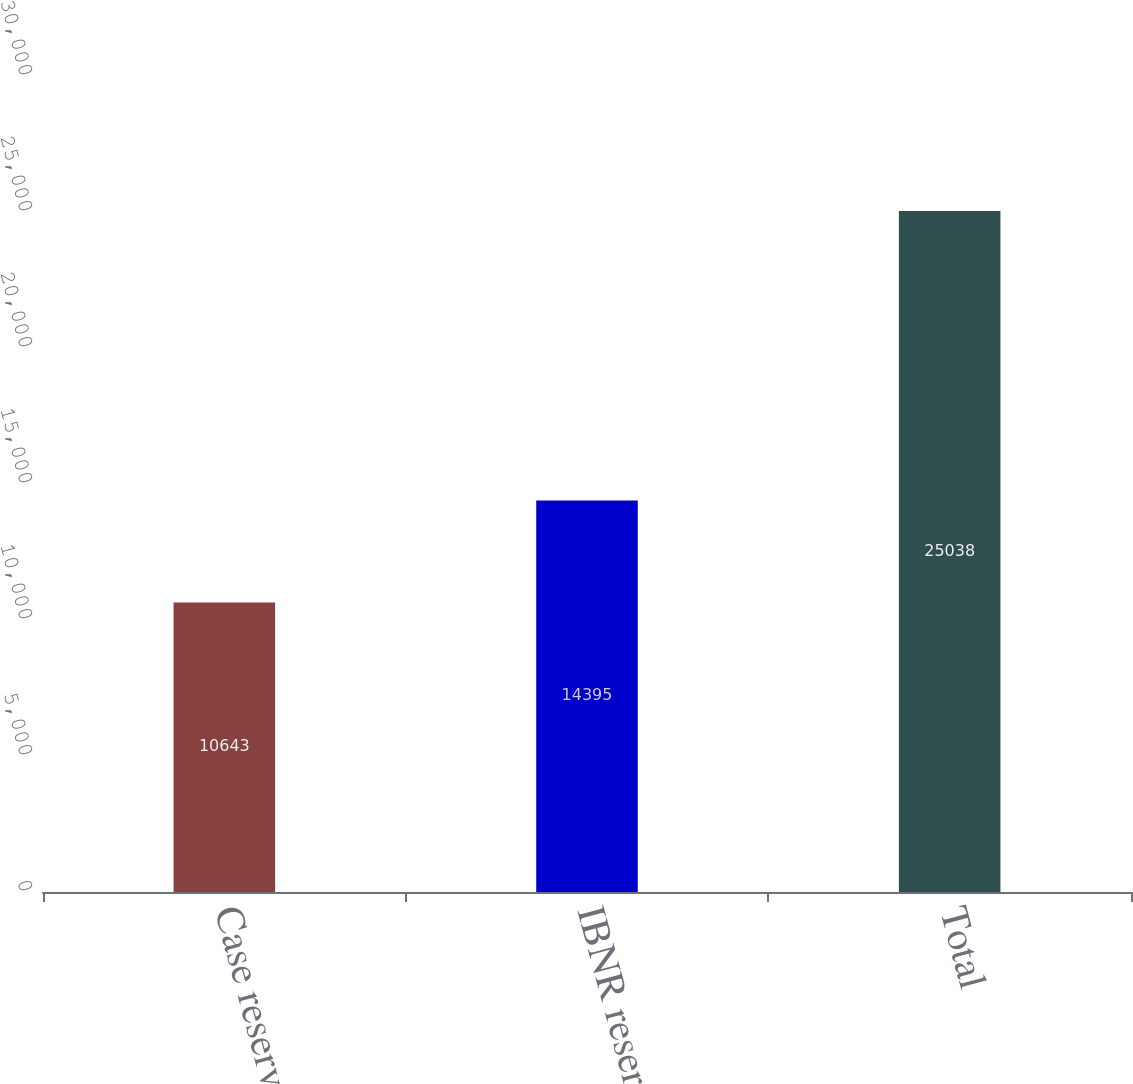Convert chart to OTSL. <chart><loc_0><loc_0><loc_500><loc_500><bar_chart><fcel>Case reserves<fcel>IBNR reserves<fcel>Total<nl><fcel>10643<fcel>14395<fcel>25038<nl></chart> 